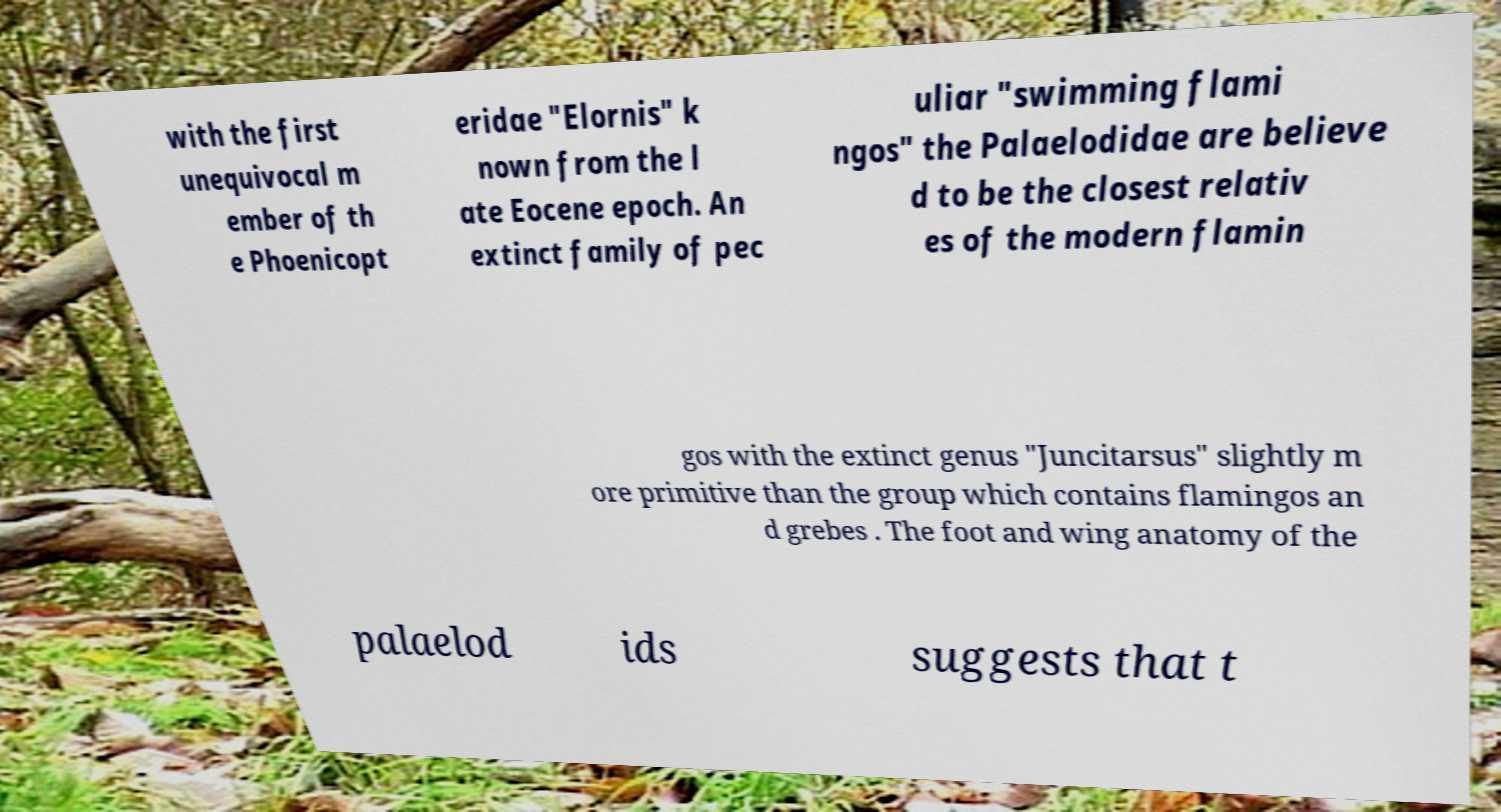Can you read and provide the text displayed in the image?This photo seems to have some interesting text. Can you extract and type it out for me? with the first unequivocal m ember of th e Phoenicopt eridae "Elornis" k nown from the l ate Eocene epoch. An extinct family of pec uliar "swimming flami ngos" the Palaelodidae are believe d to be the closest relativ es of the modern flamin gos with the extinct genus "Juncitarsus" slightly m ore primitive than the group which contains flamingos an d grebes . The foot and wing anatomy of the palaelod ids suggests that t 